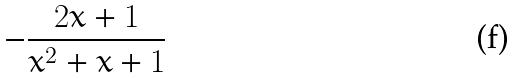Convert formula to latex. <formula><loc_0><loc_0><loc_500><loc_500>- \frac { 2 x + 1 } { x ^ { 2 } + x + 1 }</formula> 